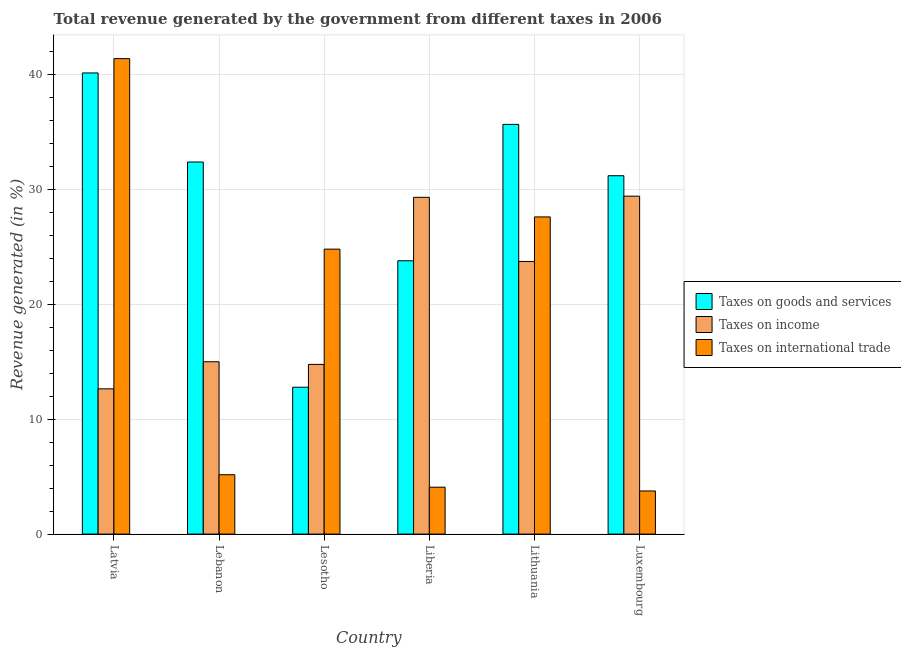How many different coloured bars are there?
Make the answer very short. 3. How many bars are there on the 4th tick from the right?
Give a very brief answer. 3. What is the label of the 4th group of bars from the left?
Give a very brief answer. Liberia. In how many cases, is the number of bars for a given country not equal to the number of legend labels?
Provide a succinct answer. 0. What is the percentage of revenue generated by taxes on income in Liberia?
Keep it short and to the point. 29.29. Across all countries, what is the maximum percentage of revenue generated by tax on international trade?
Ensure brevity in your answer.  41.35. Across all countries, what is the minimum percentage of revenue generated by taxes on income?
Keep it short and to the point. 12.63. In which country was the percentage of revenue generated by tax on international trade maximum?
Ensure brevity in your answer.  Latvia. In which country was the percentage of revenue generated by tax on international trade minimum?
Provide a succinct answer. Luxembourg. What is the total percentage of revenue generated by tax on international trade in the graph?
Your response must be concise. 106.71. What is the difference between the percentage of revenue generated by tax on international trade in Latvia and that in Lesotho?
Your response must be concise. 16.57. What is the difference between the percentage of revenue generated by taxes on goods and services in Lithuania and the percentage of revenue generated by taxes on income in Luxembourg?
Make the answer very short. 6.24. What is the average percentage of revenue generated by taxes on goods and services per country?
Your answer should be compact. 29.3. What is the difference between the percentage of revenue generated by taxes on income and percentage of revenue generated by tax on international trade in Lithuania?
Ensure brevity in your answer.  -3.88. What is the ratio of the percentage of revenue generated by taxes on goods and services in Latvia to that in Lesotho?
Offer a very short reply. 3.14. What is the difference between the highest and the second highest percentage of revenue generated by tax on international trade?
Give a very brief answer. 13.77. What is the difference between the highest and the lowest percentage of revenue generated by taxes on income?
Make the answer very short. 16.76. In how many countries, is the percentage of revenue generated by taxes on income greater than the average percentage of revenue generated by taxes on income taken over all countries?
Offer a terse response. 3. Is the sum of the percentage of revenue generated by tax on international trade in Latvia and Luxembourg greater than the maximum percentage of revenue generated by taxes on goods and services across all countries?
Your response must be concise. Yes. What does the 1st bar from the left in Liberia represents?
Offer a terse response. Taxes on goods and services. What does the 1st bar from the right in Lebanon represents?
Your answer should be very brief. Taxes on international trade. Is it the case that in every country, the sum of the percentage of revenue generated by taxes on goods and services and percentage of revenue generated by taxes on income is greater than the percentage of revenue generated by tax on international trade?
Offer a terse response. Yes. How many bars are there?
Ensure brevity in your answer.  18. Are all the bars in the graph horizontal?
Keep it short and to the point. No. Are the values on the major ticks of Y-axis written in scientific E-notation?
Give a very brief answer. No. Does the graph contain grids?
Your answer should be very brief. Yes. Where does the legend appear in the graph?
Offer a very short reply. Center right. What is the title of the graph?
Ensure brevity in your answer.  Total revenue generated by the government from different taxes in 2006. Does "Travel services" appear as one of the legend labels in the graph?
Provide a short and direct response. No. What is the label or title of the X-axis?
Give a very brief answer. Country. What is the label or title of the Y-axis?
Provide a succinct answer. Revenue generated (in %). What is the Revenue generated (in %) in Taxes on goods and services in Latvia?
Provide a succinct answer. 40.11. What is the Revenue generated (in %) in Taxes on income in Latvia?
Your answer should be very brief. 12.63. What is the Revenue generated (in %) of Taxes on international trade in Latvia?
Your answer should be compact. 41.35. What is the Revenue generated (in %) in Taxes on goods and services in Lebanon?
Keep it short and to the point. 32.36. What is the Revenue generated (in %) of Taxes on income in Lebanon?
Make the answer very short. 14.99. What is the Revenue generated (in %) in Taxes on international trade in Lebanon?
Your answer should be very brief. 5.16. What is the Revenue generated (in %) of Taxes on goods and services in Lesotho?
Ensure brevity in your answer.  12.77. What is the Revenue generated (in %) in Taxes on income in Lesotho?
Provide a succinct answer. 14.76. What is the Revenue generated (in %) of Taxes on international trade in Lesotho?
Provide a short and direct response. 24.78. What is the Revenue generated (in %) in Taxes on goods and services in Liberia?
Provide a succinct answer. 23.77. What is the Revenue generated (in %) in Taxes on income in Liberia?
Your answer should be compact. 29.29. What is the Revenue generated (in %) of Taxes on international trade in Liberia?
Give a very brief answer. 4.08. What is the Revenue generated (in %) in Taxes on goods and services in Lithuania?
Your response must be concise. 35.63. What is the Revenue generated (in %) in Taxes on income in Lithuania?
Keep it short and to the point. 23.71. What is the Revenue generated (in %) of Taxes on international trade in Lithuania?
Your response must be concise. 27.59. What is the Revenue generated (in %) in Taxes on goods and services in Luxembourg?
Offer a terse response. 31.17. What is the Revenue generated (in %) in Taxes on income in Luxembourg?
Your answer should be very brief. 29.39. What is the Revenue generated (in %) of Taxes on international trade in Luxembourg?
Your response must be concise. 3.75. Across all countries, what is the maximum Revenue generated (in %) of Taxes on goods and services?
Provide a short and direct response. 40.11. Across all countries, what is the maximum Revenue generated (in %) in Taxes on income?
Give a very brief answer. 29.39. Across all countries, what is the maximum Revenue generated (in %) of Taxes on international trade?
Keep it short and to the point. 41.35. Across all countries, what is the minimum Revenue generated (in %) of Taxes on goods and services?
Your response must be concise. 12.77. Across all countries, what is the minimum Revenue generated (in %) in Taxes on income?
Keep it short and to the point. 12.63. Across all countries, what is the minimum Revenue generated (in %) in Taxes on international trade?
Your answer should be very brief. 3.75. What is the total Revenue generated (in %) of Taxes on goods and services in the graph?
Your answer should be compact. 175.82. What is the total Revenue generated (in %) in Taxes on income in the graph?
Your response must be concise. 124.77. What is the total Revenue generated (in %) in Taxes on international trade in the graph?
Make the answer very short. 106.71. What is the difference between the Revenue generated (in %) of Taxes on goods and services in Latvia and that in Lebanon?
Make the answer very short. 7.75. What is the difference between the Revenue generated (in %) of Taxes on income in Latvia and that in Lebanon?
Offer a terse response. -2.36. What is the difference between the Revenue generated (in %) of Taxes on international trade in Latvia and that in Lebanon?
Ensure brevity in your answer.  36.19. What is the difference between the Revenue generated (in %) of Taxes on goods and services in Latvia and that in Lesotho?
Provide a short and direct response. 27.33. What is the difference between the Revenue generated (in %) of Taxes on income in Latvia and that in Lesotho?
Offer a terse response. -2.12. What is the difference between the Revenue generated (in %) of Taxes on international trade in Latvia and that in Lesotho?
Make the answer very short. 16.57. What is the difference between the Revenue generated (in %) in Taxes on goods and services in Latvia and that in Liberia?
Your response must be concise. 16.34. What is the difference between the Revenue generated (in %) of Taxes on income in Latvia and that in Liberia?
Your response must be concise. -16.66. What is the difference between the Revenue generated (in %) of Taxes on international trade in Latvia and that in Liberia?
Offer a very short reply. 37.27. What is the difference between the Revenue generated (in %) in Taxes on goods and services in Latvia and that in Lithuania?
Keep it short and to the point. 4.47. What is the difference between the Revenue generated (in %) of Taxes on income in Latvia and that in Lithuania?
Offer a terse response. -11.08. What is the difference between the Revenue generated (in %) of Taxes on international trade in Latvia and that in Lithuania?
Keep it short and to the point. 13.77. What is the difference between the Revenue generated (in %) in Taxes on goods and services in Latvia and that in Luxembourg?
Your answer should be compact. 8.94. What is the difference between the Revenue generated (in %) of Taxes on income in Latvia and that in Luxembourg?
Give a very brief answer. -16.76. What is the difference between the Revenue generated (in %) in Taxes on international trade in Latvia and that in Luxembourg?
Ensure brevity in your answer.  37.6. What is the difference between the Revenue generated (in %) in Taxes on goods and services in Lebanon and that in Lesotho?
Offer a very short reply. 19.59. What is the difference between the Revenue generated (in %) in Taxes on income in Lebanon and that in Lesotho?
Provide a succinct answer. 0.23. What is the difference between the Revenue generated (in %) of Taxes on international trade in Lebanon and that in Lesotho?
Your answer should be very brief. -19.62. What is the difference between the Revenue generated (in %) in Taxes on goods and services in Lebanon and that in Liberia?
Your response must be concise. 8.59. What is the difference between the Revenue generated (in %) in Taxes on income in Lebanon and that in Liberia?
Ensure brevity in your answer.  -14.3. What is the difference between the Revenue generated (in %) in Taxes on international trade in Lebanon and that in Liberia?
Make the answer very short. 1.08. What is the difference between the Revenue generated (in %) in Taxes on goods and services in Lebanon and that in Lithuania?
Provide a short and direct response. -3.27. What is the difference between the Revenue generated (in %) of Taxes on income in Lebanon and that in Lithuania?
Your answer should be compact. -8.72. What is the difference between the Revenue generated (in %) of Taxes on international trade in Lebanon and that in Lithuania?
Keep it short and to the point. -22.42. What is the difference between the Revenue generated (in %) of Taxes on goods and services in Lebanon and that in Luxembourg?
Offer a terse response. 1.19. What is the difference between the Revenue generated (in %) in Taxes on income in Lebanon and that in Luxembourg?
Ensure brevity in your answer.  -14.4. What is the difference between the Revenue generated (in %) of Taxes on international trade in Lebanon and that in Luxembourg?
Offer a very short reply. 1.41. What is the difference between the Revenue generated (in %) of Taxes on goods and services in Lesotho and that in Liberia?
Keep it short and to the point. -11. What is the difference between the Revenue generated (in %) of Taxes on income in Lesotho and that in Liberia?
Your answer should be compact. -14.53. What is the difference between the Revenue generated (in %) in Taxes on international trade in Lesotho and that in Liberia?
Provide a short and direct response. 20.7. What is the difference between the Revenue generated (in %) in Taxes on goods and services in Lesotho and that in Lithuania?
Offer a very short reply. -22.86. What is the difference between the Revenue generated (in %) of Taxes on income in Lesotho and that in Lithuania?
Give a very brief answer. -8.95. What is the difference between the Revenue generated (in %) in Taxes on international trade in Lesotho and that in Lithuania?
Provide a succinct answer. -2.8. What is the difference between the Revenue generated (in %) in Taxes on goods and services in Lesotho and that in Luxembourg?
Your answer should be compact. -18.39. What is the difference between the Revenue generated (in %) of Taxes on income in Lesotho and that in Luxembourg?
Make the answer very short. -14.63. What is the difference between the Revenue generated (in %) in Taxes on international trade in Lesotho and that in Luxembourg?
Ensure brevity in your answer.  21.03. What is the difference between the Revenue generated (in %) of Taxes on goods and services in Liberia and that in Lithuania?
Your answer should be compact. -11.86. What is the difference between the Revenue generated (in %) in Taxes on income in Liberia and that in Lithuania?
Keep it short and to the point. 5.58. What is the difference between the Revenue generated (in %) in Taxes on international trade in Liberia and that in Lithuania?
Ensure brevity in your answer.  -23.51. What is the difference between the Revenue generated (in %) of Taxes on goods and services in Liberia and that in Luxembourg?
Give a very brief answer. -7.4. What is the difference between the Revenue generated (in %) in Taxes on income in Liberia and that in Luxembourg?
Provide a succinct answer. -0.1. What is the difference between the Revenue generated (in %) of Taxes on international trade in Liberia and that in Luxembourg?
Your answer should be very brief. 0.33. What is the difference between the Revenue generated (in %) in Taxes on goods and services in Lithuania and that in Luxembourg?
Offer a terse response. 4.46. What is the difference between the Revenue generated (in %) in Taxes on income in Lithuania and that in Luxembourg?
Your answer should be compact. -5.68. What is the difference between the Revenue generated (in %) of Taxes on international trade in Lithuania and that in Luxembourg?
Offer a very short reply. 23.83. What is the difference between the Revenue generated (in %) in Taxes on goods and services in Latvia and the Revenue generated (in %) in Taxes on income in Lebanon?
Provide a short and direct response. 25.12. What is the difference between the Revenue generated (in %) in Taxes on goods and services in Latvia and the Revenue generated (in %) in Taxes on international trade in Lebanon?
Provide a succinct answer. 34.94. What is the difference between the Revenue generated (in %) of Taxes on income in Latvia and the Revenue generated (in %) of Taxes on international trade in Lebanon?
Your response must be concise. 7.47. What is the difference between the Revenue generated (in %) of Taxes on goods and services in Latvia and the Revenue generated (in %) of Taxes on income in Lesotho?
Provide a short and direct response. 25.35. What is the difference between the Revenue generated (in %) of Taxes on goods and services in Latvia and the Revenue generated (in %) of Taxes on international trade in Lesotho?
Ensure brevity in your answer.  15.32. What is the difference between the Revenue generated (in %) of Taxes on income in Latvia and the Revenue generated (in %) of Taxes on international trade in Lesotho?
Provide a succinct answer. -12.15. What is the difference between the Revenue generated (in %) in Taxes on goods and services in Latvia and the Revenue generated (in %) in Taxes on income in Liberia?
Ensure brevity in your answer.  10.82. What is the difference between the Revenue generated (in %) in Taxes on goods and services in Latvia and the Revenue generated (in %) in Taxes on international trade in Liberia?
Your response must be concise. 36.03. What is the difference between the Revenue generated (in %) in Taxes on income in Latvia and the Revenue generated (in %) in Taxes on international trade in Liberia?
Your answer should be compact. 8.55. What is the difference between the Revenue generated (in %) of Taxes on goods and services in Latvia and the Revenue generated (in %) of Taxes on income in Lithuania?
Give a very brief answer. 16.4. What is the difference between the Revenue generated (in %) in Taxes on goods and services in Latvia and the Revenue generated (in %) in Taxes on international trade in Lithuania?
Provide a short and direct response. 12.52. What is the difference between the Revenue generated (in %) of Taxes on income in Latvia and the Revenue generated (in %) of Taxes on international trade in Lithuania?
Give a very brief answer. -14.95. What is the difference between the Revenue generated (in %) of Taxes on goods and services in Latvia and the Revenue generated (in %) of Taxes on income in Luxembourg?
Offer a terse response. 10.72. What is the difference between the Revenue generated (in %) in Taxes on goods and services in Latvia and the Revenue generated (in %) in Taxes on international trade in Luxembourg?
Provide a short and direct response. 36.35. What is the difference between the Revenue generated (in %) of Taxes on income in Latvia and the Revenue generated (in %) of Taxes on international trade in Luxembourg?
Your response must be concise. 8.88. What is the difference between the Revenue generated (in %) in Taxes on goods and services in Lebanon and the Revenue generated (in %) in Taxes on income in Lesotho?
Give a very brief answer. 17.6. What is the difference between the Revenue generated (in %) of Taxes on goods and services in Lebanon and the Revenue generated (in %) of Taxes on international trade in Lesotho?
Your answer should be compact. 7.58. What is the difference between the Revenue generated (in %) in Taxes on income in Lebanon and the Revenue generated (in %) in Taxes on international trade in Lesotho?
Make the answer very short. -9.79. What is the difference between the Revenue generated (in %) of Taxes on goods and services in Lebanon and the Revenue generated (in %) of Taxes on income in Liberia?
Your answer should be very brief. 3.07. What is the difference between the Revenue generated (in %) of Taxes on goods and services in Lebanon and the Revenue generated (in %) of Taxes on international trade in Liberia?
Provide a succinct answer. 28.28. What is the difference between the Revenue generated (in %) of Taxes on income in Lebanon and the Revenue generated (in %) of Taxes on international trade in Liberia?
Your answer should be very brief. 10.91. What is the difference between the Revenue generated (in %) in Taxes on goods and services in Lebanon and the Revenue generated (in %) in Taxes on income in Lithuania?
Make the answer very short. 8.65. What is the difference between the Revenue generated (in %) in Taxes on goods and services in Lebanon and the Revenue generated (in %) in Taxes on international trade in Lithuania?
Make the answer very short. 4.78. What is the difference between the Revenue generated (in %) of Taxes on income in Lebanon and the Revenue generated (in %) of Taxes on international trade in Lithuania?
Ensure brevity in your answer.  -12.59. What is the difference between the Revenue generated (in %) in Taxes on goods and services in Lebanon and the Revenue generated (in %) in Taxes on income in Luxembourg?
Offer a very short reply. 2.97. What is the difference between the Revenue generated (in %) of Taxes on goods and services in Lebanon and the Revenue generated (in %) of Taxes on international trade in Luxembourg?
Provide a short and direct response. 28.61. What is the difference between the Revenue generated (in %) of Taxes on income in Lebanon and the Revenue generated (in %) of Taxes on international trade in Luxembourg?
Make the answer very short. 11.24. What is the difference between the Revenue generated (in %) of Taxes on goods and services in Lesotho and the Revenue generated (in %) of Taxes on income in Liberia?
Give a very brief answer. -16.52. What is the difference between the Revenue generated (in %) in Taxes on goods and services in Lesotho and the Revenue generated (in %) in Taxes on international trade in Liberia?
Make the answer very short. 8.69. What is the difference between the Revenue generated (in %) in Taxes on income in Lesotho and the Revenue generated (in %) in Taxes on international trade in Liberia?
Your answer should be compact. 10.68. What is the difference between the Revenue generated (in %) of Taxes on goods and services in Lesotho and the Revenue generated (in %) of Taxes on income in Lithuania?
Your response must be concise. -10.94. What is the difference between the Revenue generated (in %) in Taxes on goods and services in Lesotho and the Revenue generated (in %) in Taxes on international trade in Lithuania?
Ensure brevity in your answer.  -14.81. What is the difference between the Revenue generated (in %) of Taxes on income in Lesotho and the Revenue generated (in %) of Taxes on international trade in Lithuania?
Your answer should be compact. -12.83. What is the difference between the Revenue generated (in %) of Taxes on goods and services in Lesotho and the Revenue generated (in %) of Taxes on income in Luxembourg?
Provide a short and direct response. -16.62. What is the difference between the Revenue generated (in %) in Taxes on goods and services in Lesotho and the Revenue generated (in %) in Taxes on international trade in Luxembourg?
Ensure brevity in your answer.  9.02. What is the difference between the Revenue generated (in %) in Taxes on income in Lesotho and the Revenue generated (in %) in Taxes on international trade in Luxembourg?
Provide a succinct answer. 11.01. What is the difference between the Revenue generated (in %) in Taxes on goods and services in Liberia and the Revenue generated (in %) in Taxes on income in Lithuania?
Offer a very short reply. 0.06. What is the difference between the Revenue generated (in %) in Taxes on goods and services in Liberia and the Revenue generated (in %) in Taxes on international trade in Lithuania?
Offer a terse response. -3.81. What is the difference between the Revenue generated (in %) of Taxes on income in Liberia and the Revenue generated (in %) of Taxes on international trade in Lithuania?
Make the answer very short. 1.71. What is the difference between the Revenue generated (in %) in Taxes on goods and services in Liberia and the Revenue generated (in %) in Taxes on income in Luxembourg?
Provide a short and direct response. -5.62. What is the difference between the Revenue generated (in %) in Taxes on goods and services in Liberia and the Revenue generated (in %) in Taxes on international trade in Luxembourg?
Provide a short and direct response. 20.02. What is the difference between the Revenue generated (in %) in Taxes on income in Liberia and the Revenue generated (in %) in Taxes on international trade in Luxembourg?
Provide a short and direct response. 25.54. What is the difference between the Revenue generated (in %) in Taxes on goods and services in Lithuania and the Revenue generated (in %) in Taxes on income in Luxembourg?
Your answer should be very brief. 6.24. What is the difference between the Revenue generated (in %) of Taxes on goods and services in Lithuania and the Revenue generated (in %) of Taxes on international trade in Luxembourg?
Your answer should be compact. 31.88. What is the difference between the Revenue generated (in %) of Taxes on income in Lithuania and the Revenue generated (in %) of Taxes on international trade in Luxembourg?
Offer a terse response. 19.96. What is the average Revenue generated (in %) in Taxes on goods and services per country?
Ensure brevity in your answer.  29.3. What is the average Revenue generated (in %) in Taxes on income per country?
Make the answer very short. 20.8. What is the average Revenue generated (in %) of Taxes on international trade per country?
Provide a succinct answer. 17.79. What is the difference between the Revenue generated (in %) of Taxes on goods and services and Revenue generated (in %) of Taxes on income in Latvia?
Your answer should be very brief. 27.47. What is the difference between the Revenue generated (in %) in Taxes on goods and services and Revenue generated (in %) in Taxes on international trade in Latvia?
Provide a succinct answer. -1.24. What is the difference between the Revenue generated (in %) in Taxes on income and Revenue generated (in %) in Taxes on international trade in Latvia?
Provide a short and direct response. -28.72. What is the difference between the Revenue generated (in %) of Taxes on goods and services and Revenue generated (in %) of Taxes on income in Lebanon?
Make the answer very short. 17.37. What is the difference between the Revenue generated (in %) in Taxes on goods and services and Revenue generated (in %) in Taxes on international trade in Lebanon?
Offer a very short reply. 27.2. What is the difference between the Revenue generated (in %) of Taxes on income and Revenue generated (in %) of Taxes on international trade in Lebanon?
Offer a very short reply. 9.83. What is the difference between the Revenue generated (in %) in Taxes on goods and services and Revenue generated (in %) in Taxes on income in Lesotho?
Ensure brevity in your answer.  -1.98. What is the difference between the Revenue generated (in %) in Taxes on goods and services and Revenue generated (in %) in Taxes on international trade in Lesotho?
Your answer should be very brief. -12.01. What is the difference between the Revenue generated (in %) in Taxes on income and Revenue generated (in %) in Taxes on international trade in Lesotho?
Offer a terse response. -10.02. What is the difference between the Revenue generated (in %) in Taxes on goods and services and Revenue generated (in %) in Taxes on income in Liberia?
Ensure brevity in your answer.  -5.52. What is the difference between the Revenue generated (in %) of Taxes on goods and services and Revenue generated (in %) of Taxes on international trade in Liberia?
Provide a short and direct response. 19.69. What is the difference between the Revenue generated (in %) in Taxes on income and Revenue generated (in %) in Taxes on international trade in Liberia?
Your answer should be very brief. 25.21. What is the difference between the Revenue generated (in %) of Taxes on goods and services and Revenue generated (in %) of Taxes on income in Lithuania?
Make the answer very short. 11.92. What is the difference between the Revenue generated (in %) of Taxes on goods and services and Revenue generated (in %) of Taxes on international trade in Lithuania?
Provide a short and direct response. 8.05. What is the difference between the Revenue generated (in %) of Taxes on income and Revenue generated (in %) of Taxes on international trade in Lithuania?
Make the answer very short. -3.88. What is the difference between the Revenue generated (in %) in Taxes on goods and services and Revenue generated (in %) in Taxes on income in Luxembourg?
Ensure brevity in your answer.  1.78. What is the difference between the Revenue generated (in %) of Taxes on goods and services and Revenue generated (in %) of Taxes on international trade in Luxembourg?
Provide a short and direct response. 27.42. What is the difference between the Revenue generated (in %) of Taxes on income and Revenue generated (in %) of Taxes on international trade in Luxembourg?
Make the answer very short. 25.64. What is the ratio of the Revenue generated (in %) of Taxes on goods and services in Latvia to that in Lebanon?
Provide a succinct answer. 1.24. What is the ratio of the Revenue generated (in %) in Taxes on income in Latvia to that in Lebanon?
Make the answer very short. 0.84. What is the ratio of the Revenue generated (in %) in Taxes on international trade in Latvia to that in Lebanon?
Provide a short and direct response. 8.01. What is the ratio of the Revenue generated (in %) in Taxes on goods and services in Latvia to that in Lesotho?
Offer a very short reply. 3.14. What is the ratio of the Revenue generated (in %) of Taxes on income in Latvia to that in Lesotho?
Ensure brevity in your answer.  0.86. What is the ratio of the Revenue generated (in %) in Taxes on international trade in Latvia to that in Lesotho?
Make the answer very short. 1.67. What is the ratio of the Revenue generated (in %) of Taxes on goods and services in Latvia to that in Liberia?
Your response must be concise. 1.69. What is the ratio of the Revenue generated (in %) in Taxes on income in Latvia to that in Liberia?
Your response must be concise. 0.43. What is the ratio of the Revenue generated (in %) in Taxes on international trade in Latvia to that in Liberia?
Offer a terse response. 10.14. What is the ratio of the Revenue generated (in %) of Taxes on goods and services in Latvia to that in Lithuania?
Give a very brief answer. 1.13. What is the ratio of the Revenue generated (in %) of Taxes on income in Latvia to that in Lithuania?
Your response must be concise. 0.53. What is the ratio of the Revenue generated (in %) in Taxes on international trade in Latvia to that in Lithuania?
Make the answer very short. 1.5. What is the ratio of the Revenue generated (in %) in Taxes on goods and services in Latvia to that in Luxembourg?
Offer a terse response. 1.29. What is the ratio of the Revenue generated (in %) of Taxes on income in Latvia to that in Luxembourg?
Keep it short and to the point. 0.43. What is the ratio of the Revenue generated (in %) in Taxes on international trade in Latvia to that in Luxembourg?
Your response must be concise. 11.02. What is the ratio of the Revenue generated (in %) of Taxes on goods and services in Lebanon to that in Lesotho?
Make the answer very short. 2.53. What is the ratio of the Revenue generated (in %) in Taxes on income in Lebanon to that in Lesotho?
Provide a succinct answer. 1.02. What is the ratio of the Revenue generated (in %) of Taxes on international trade in Lebanon to that in Lesotho?
Offer a terse response. 0.21. What is the ratio of the Revenue generated (in %) of Taxes on goods and services in Lebanon to that in Liberia?
Provide a short and direct response. 1.36. What is the ratio of the Revenue generated (in %) in Taxes on income in Lebanon to that in Liberia?
Provide a succinct answer. 0.51. What is the ratio of the Revenue generated (in %) in Taxes on international trade in Lebanon to that in Liberia?
Offer a very short reply. 1.27. What is the ratio of the Revenue generated (in %) of Taxes on goods and services in Lebanon to that in Lithuania?
Make the answer very short. 0.91. What is the ratio of the Revenue generated (in %) in Taxes on income in Lebanon to that in Lithuania?
Ensure brevity in your answer.  0.63. What is the ratio of the Revenue generated (in %) in Taxes on international trade in Lebanon to that in Lithuania?
Provide a short and direct response. 0.19. What is the ratio of the Revenue generated (in %) in Taxes on goods and services in Lebanon to that in Luxembourg?
Offer a terse response. 1.04. What is the ratio of the Revenue generated (in %) of Taxes on income in Lebanon to that in Luxembourg?
Provide a short and direct response. 0.51. What is the ratio of the Revenue generated (in %) of Taxes on international trade in Lebanon to that in Luxembourg?
Offer a terse response. 1.38. What is the ratio of the Revenue generated (in %) of Taxes on goods and services in Lesotho to that in Liberia?
Make the answer very short. 0.54. What is the ratio of the Revenue generated (in %) of Taxes on income in Lesotho to that in Liberia?
Make the answer very short. 0.5. What is the ratio of the Revenue generated (in %) in Taxes on international trade in Lesotho to that in Liberia?
Your answer should be compact. 6.07. What is the ratio of the Revenue generated (in %) in Taxes on goods and services in Lesotho to that in Lithuania?
Your answer should be very brief. 0.36. What is the ratio of the Revenue generated (in %) of Taxes on income in Lesotho to that in Lithuania?
Ensure brevity in your answer.  0.62. What is the ratio of the Revenue generated (in %) of Taxes on international trade in Lesotho to that in Lithuania?
Ensure brevity in your answer.  0.9. What is the ratio of the Revenue generated (in %) of Taxes on goods and services in Lesotho to that in Luxembourg?
Make the answer very short. 0.41. What is the ratio of the Revenue generated (in %) of Taxes on income in Lesotho to that in Luxembourg?
Your response must be concise. 0.5. What is the ratio of the Revenue generated (in %) in Taxes on international trade in Lesotho to that in Luxembourg?
Your response must be concise. 6.6. What is the ratio of the Revenue generated (in %) in Taxes on goods and services in Liberia to that in Lithuania?
Your response must be concise. 0.67. What is the ratio of the Revenue generated (in %) in Taxes on income in Liberia to that in Lithuania?
Keep it short and to the point. 1.24. What is the ratio of the Revenue generated (in %) of Taxes on international trade in Liberia to that in Lithuania?
Provide a succinct answer. 0.15. What is the ratio of the Revenue generated (in %) of Taxes on goods and services in Liberia to that in Luxembourg?
Provide a succinct answer. 0.76. What is the ratio of the Revenue generated (in %) in Taxes on international trade in Liberia to that in Luxembourg?
Make the answer very short. 1.09. What is the ratio of the Revenue generated (in %) in Taxes on goods and services in Lithuania to that in Luxembourg?
Provide a short and direct response. 1.14. What is the ratio of the Revenue generated (in %) of Taxes on income in Lithuania to that in Luxembourg?
Your response must be concise. 0.81. What is the ratio of the Revenue generated (in %) in Taxes on international trade in Lithuania to that in Luxembourg?
Provide a succinct answer. 7.35. What is the difference between the highest and the second highest Revenue generated (in %) of Taxes on goods and services?
Provide a short and direct response. 4.47. What is the difference between the highest and the second highest Revenue generated (in %) of Taxes on income?
Provide a short and direct response. 0.1. What is the difference between the highest and the second highest Revenue generated (in %) in Taxes on international trade?
Your response must be concise. 13.77. What is the difference between the highest and the lowest Revenue generated (in %) of Taxes on goods and services?
Provide a short and direct response. 27.33. What is the difference between the highest and the lowest Revenue generated (in %) in Taxes on income?
Provide a short and direct response. 16.76. What is the difference between the highest and the lowest Revenue generated (in %) in Taxes on international trade?
Give a very brief answer. 37.6. 